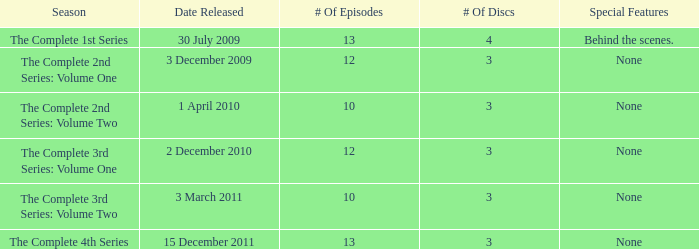What is the total number of discs for the 4th series? 3.0. 